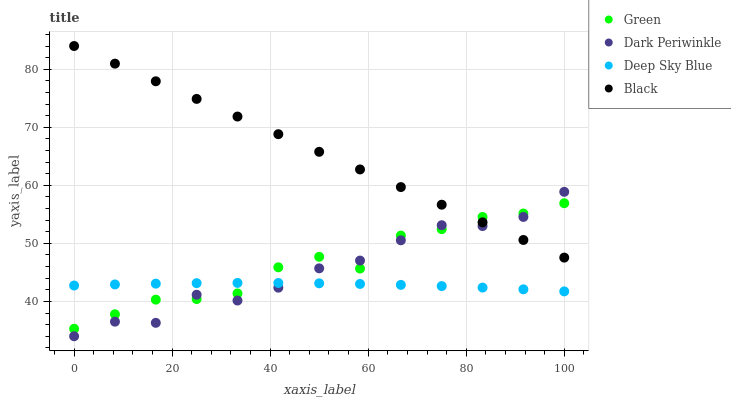Does Deep Sky Blue have the minimum area under the curve?
Answer yes or no. Yes. Does Black have the maximum area under the curve?
Answer yes or no. Yes. Does Green have the minimum area under the curve?
Answer yes or no. No. Does Green have the maximum area under the curve?
Answer yes or no. No. Is Black the smoothest?
Answer yes or no. Yes. Is Dark Periwinkle the roughest?
Answer yes or no. Yes. Is Green the smoothest?
Answer yes or no. No. Is Green the roughest?
Answer yes or no. No. Does Dark Periwinkle have the lowest value?
Answer yes or no. Yes. Does Green have the lowest value?
Answer yes or no. No. Does Black have the highest value?
Answer yes or no. Yes. Does Green have the highest value?
Answer yes or no. No. Is Deep Sky Blue less than Black?
Answer yes or no. Yes. Is Black greater than Deep Sky Blue?
Answer yes or no. Yes. Does Green intersect Dark Periwinkle?
Answer yes or no. Yes. Is Green less than Dark Periwinkle?
Answer yes or no. No. Is Green greater than Dark Periwinkle?
Answer yes or no. No. Does Deep Sky Blue intersect Black?
Answer yes or no. No. 